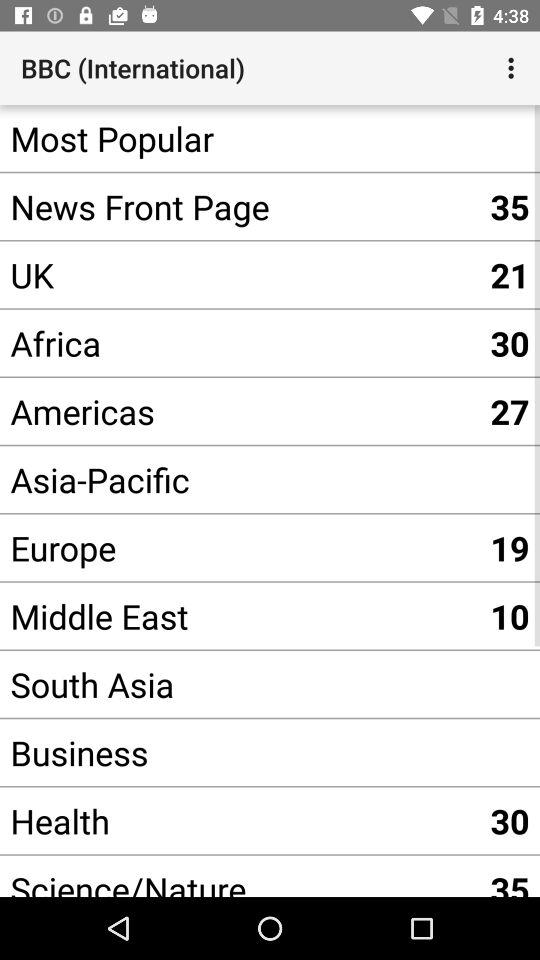What is the number shown for the news front page? The number shown for the news front page is 35. 